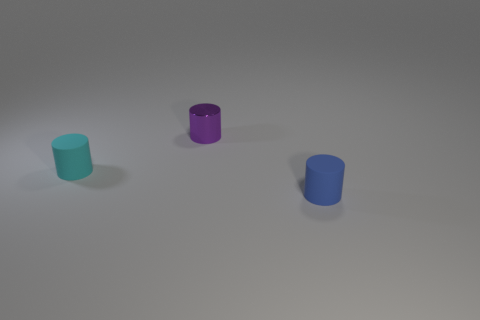Add 3 tiny cyan spheres. How many objects exist? 6 Add 1 blue matte cylinders. How many blue matte cylinders exist? 2 Subtract 0 yellow blocks. How many objects are left? 3 Subtract all purple metal things. Subtract all green things. How many objects are left? 2 Add 1 small blue rubber things. How many small blue rubber things are left? 2 